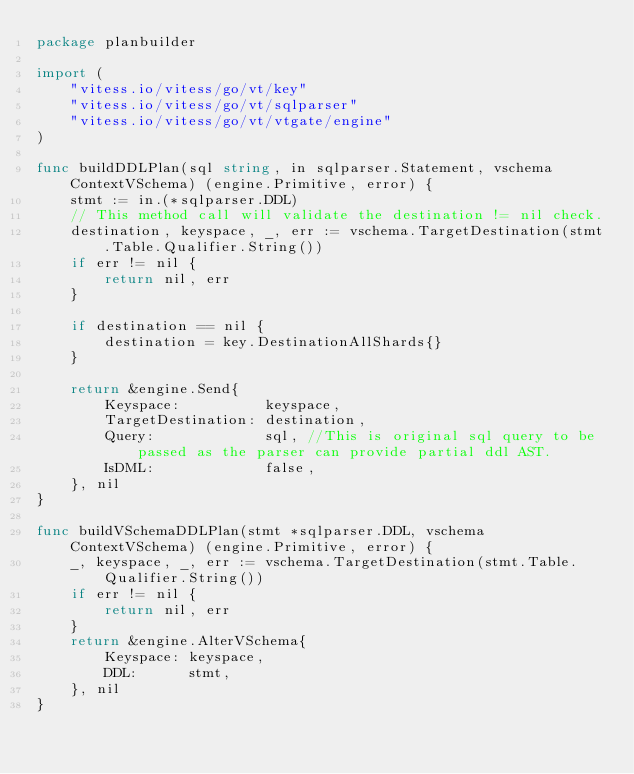Convert code to text. <code><loc_0><loc_0><loc_500><loc_500><_Go_>package planbuilder

import (
	"vitess.io/vitess/go/vt/key"
	"vitess.io/vitess/go/vt/sqlparser"
	"vitess.io/vitess/go/vt/vtgate/engine"
)

func buildDDLPlan(sql string, in sqlparser.Statement, vschema ContextVSchema) (engine.Primitive, error) {
	stmt := in.(*sqlparser.DDL)
	// This method call will validate the destination != nil check.
	destination, keyspace, _, err := vschema.TargetDestination(stmt.Table.Qualifier.String())
	if err != nil {
		return nil, err
	}

	if destination == nil {
		destination = key.DestinationAllShards{}
	}

	return &engine.Send{
		Keyspace:          keyspace,
		TargetDestination: destination,
		Query:             sql, //This is original sql query to be passed as the parser can provide partial ddl AST.
		IsDML:             false,
	}, nil
}

func buildVSchemaDDLPlan(stmt *sqlparser.DDL, vschema ContextVSchema) (engine.Primitive, error) {
	_, keyspace, _, err := vschema.TargetDestination(stmt.Table.Qualifier.String())
	if err != nil {
		return nil, err
	}
	return &engine.AlterVSchema{
		Keyspace: keyspace,
		DDL:      stmt,
	}, nil
}
</code> 